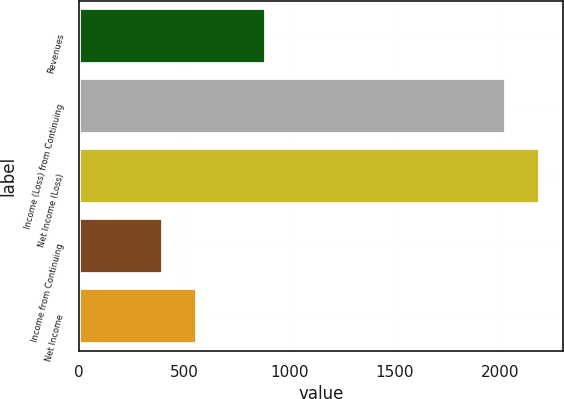Convert chart to OTSL. <chart><loc_0><loc_0><loc_500><loc_500><bar_chart><fcel>Revenues<fcel>Income (Loss) from Continuing<fcel>Net Income (Loss)<fcel>Income from Continuing<fcel>Net Income<nl><fcel>889.8<fcel>2028<fcel>2190.6<fcel>402<fcel>564.6<nl></chart> 